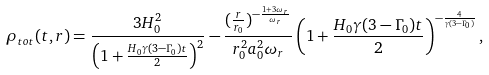Convert formula to latex. <formula><loc_0><loc_0><loc_500><loc_500>\rho _ { t o t } ( t , r ) = \frac { 3 H _ { 0 } ^ { 2 } } { \left ( 1 + \frac { H _ { 0 } \gamma ( 3 - \Gamma _ { 0 } ) t } { 2 } \right ) ^ { 2 } } - \frac { ( \frac { r } { r _ { 0 } } ) ^ { - \frac { 1 + 3 \omega _ { r } } { \omega _ { r } } } } { r _ { 0 } ^ { 2 } a _ { 0 } ^ { 2 } \omega _ { r } } \left ( 1 + \frac { H _ { 0 } \gamma ( 3 - \Gamma _ { 0 } ) t } { 2 } \right ) ^ { - \frac { 4 } { \gamma ( 3 - \Gamma _ { 0 } ) } } ,</formula> 